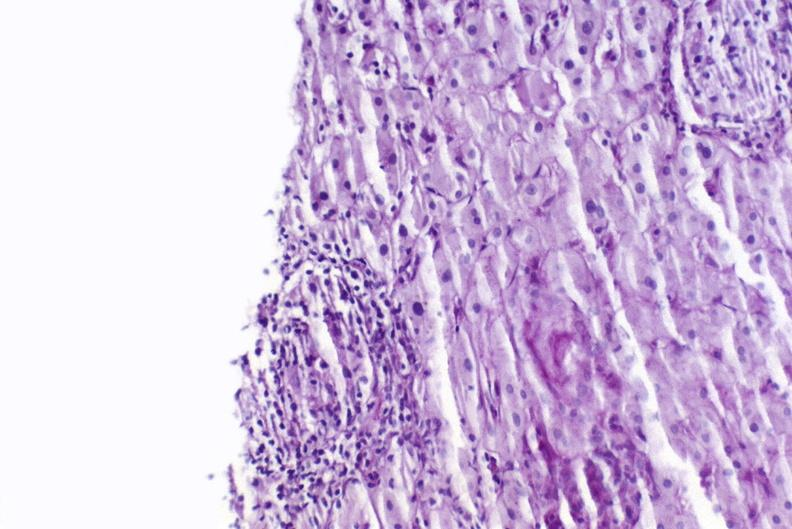what is present?
Answer the question using a single word or phrase. Hepatobiliary 